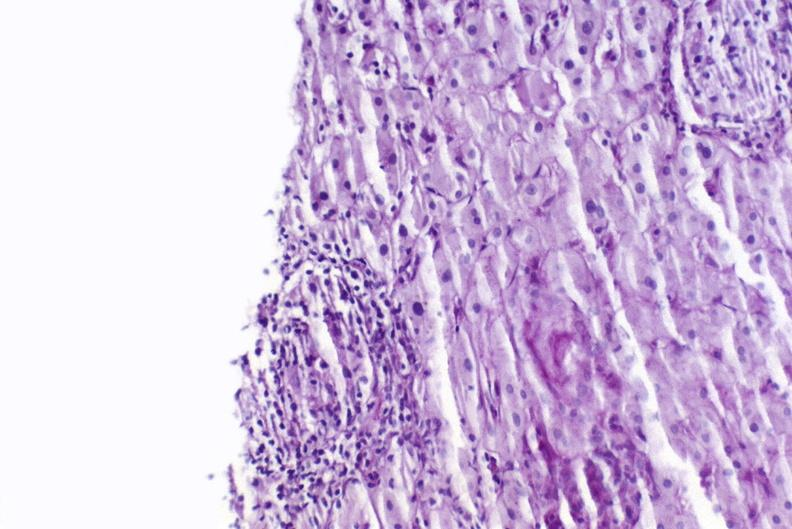what is present?
Answer the question using a single word or phrase. Hepatobiliary 